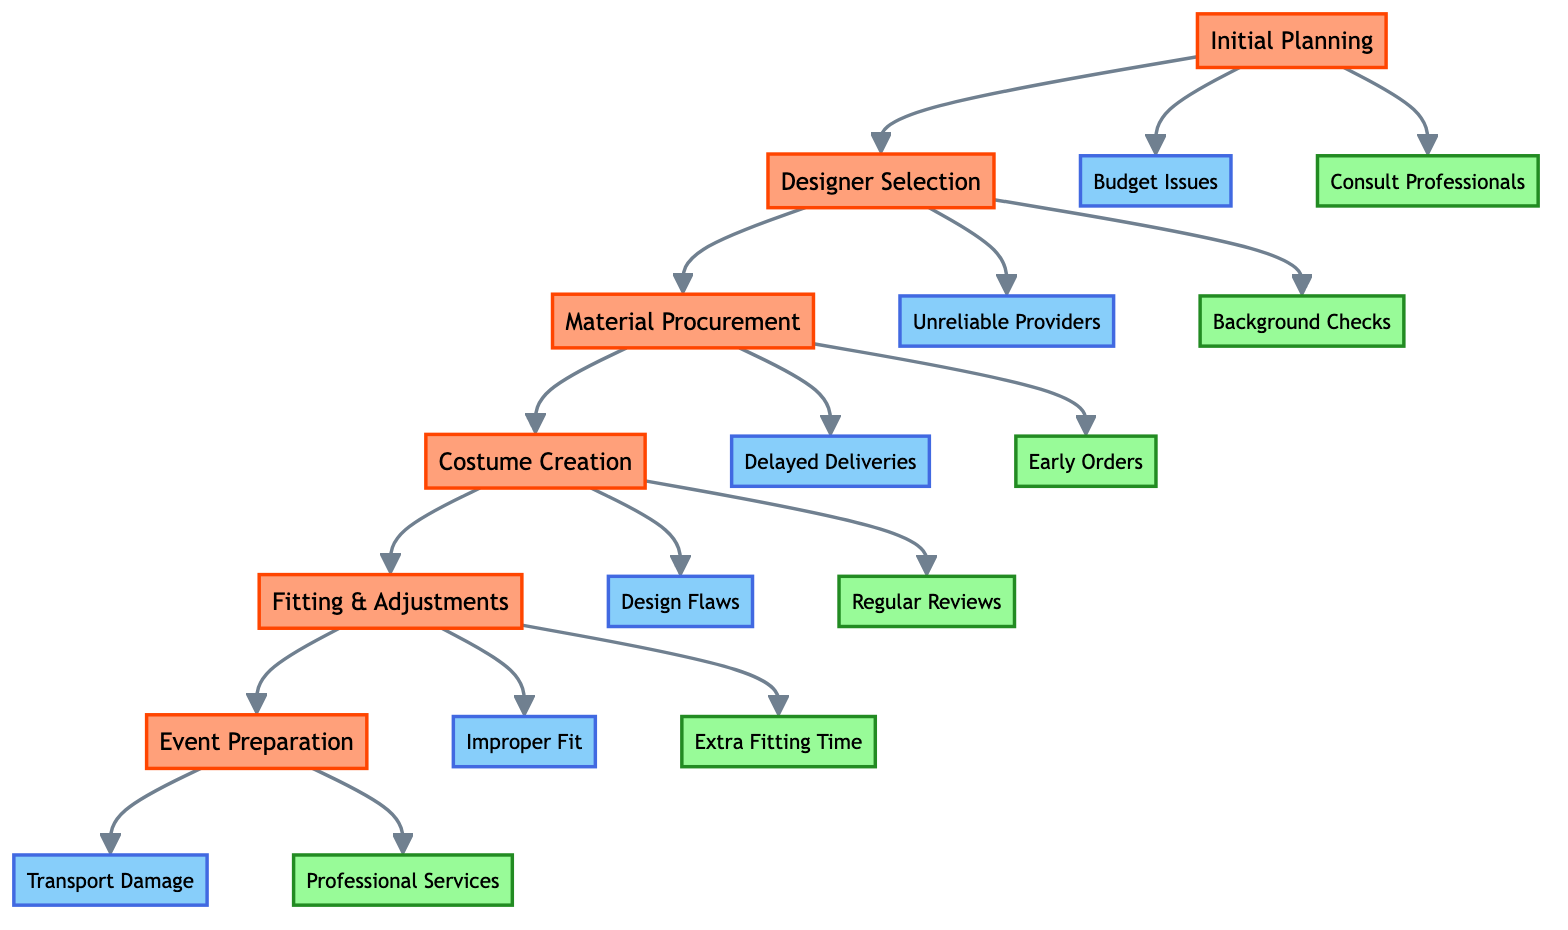What is the first step in the clinical pathway? The diagram begins with the first step labeled "Initial Planning" which indicates the starting point of the process for risk management in costume creation.
Answer: Initial Planning How many risk factors are associated with the "Costume Creation" step? In the "Costume Creation" section, there are two risk factors listed: "Design Flaws" and "Time Overruns", making a total count of two.
Answer: Two What action follows "Designer Selection" in the pathway? After "Designer Selection," the next action indicated in the pathway is "Material Procurement," connecting these two steps sequentially.
Answer: Material Procurement Which mitigation strategy is linked to the risk factor "Defective Materials"? The risk factor "Defective Materials" is mitigated by the strategy "Inspect Materials upon Arrival," as detailed in the section for "Material Procurement."
Answer: Inspect Materials upon Arrival What is the last step before "Event Preparation"? The step that precedes "Event Preparation" is "Fitting & Adjustments," which is the final adjustment stage before preparing for the event.
Answer: Fitting & Adjustments What step has a mitigation strategy of "Maintain Open Communication with Designers"? This mitigation strategy is connected to the "Costume Creation" step, where it is suggested to ensure effective collaboration during the design process.
Answer: Costume Creation What risk factor is associated with the "Material Procurement" step? The risk factor listed for "Material Procurement" is "Delayed Deliveries," indicating a potential challenge in the procurement process.
Answer: Delayed Deliveries How many overall steps are included in the clinical pathway? The diagram includes a total of five main steps: Initial Planning, Designer Selection, Material Procurement, Costume Creation, and Event Preparation, leading to a count of five.
Answer: Five What does the step "Fitting & Adjustments" emphasize as a mitigation strategy? The "Fitting & Adjustments" step emphasizes "Allow Extra Time for Fittings" as a crucial mitigation strategy to handle the risk of improper fit.
Answer: Allow Extra Time for Fittings 